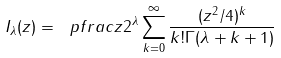Convert formula to latex. <formula><loc_0><loc_0><loc_500><loc_500>I _ { \lambda } ( z ) = \ p f r a c z 2 ^ { \lambda } \sum _ { k = 0 } ^ { \infty } \frac { ( z ^ { 2 } / 4 ) ^ { k } } { k ! \Gamma ( \lambda + k + 1 ) }</formula> 